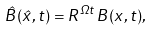Convert formula to latex. <formula><loc_0><loc_0><loc_500><loc_500>\hat { B } ( \hat { x } , t ) = R ^ { \Omega t } \, B ( x , t ) ,</formula> 